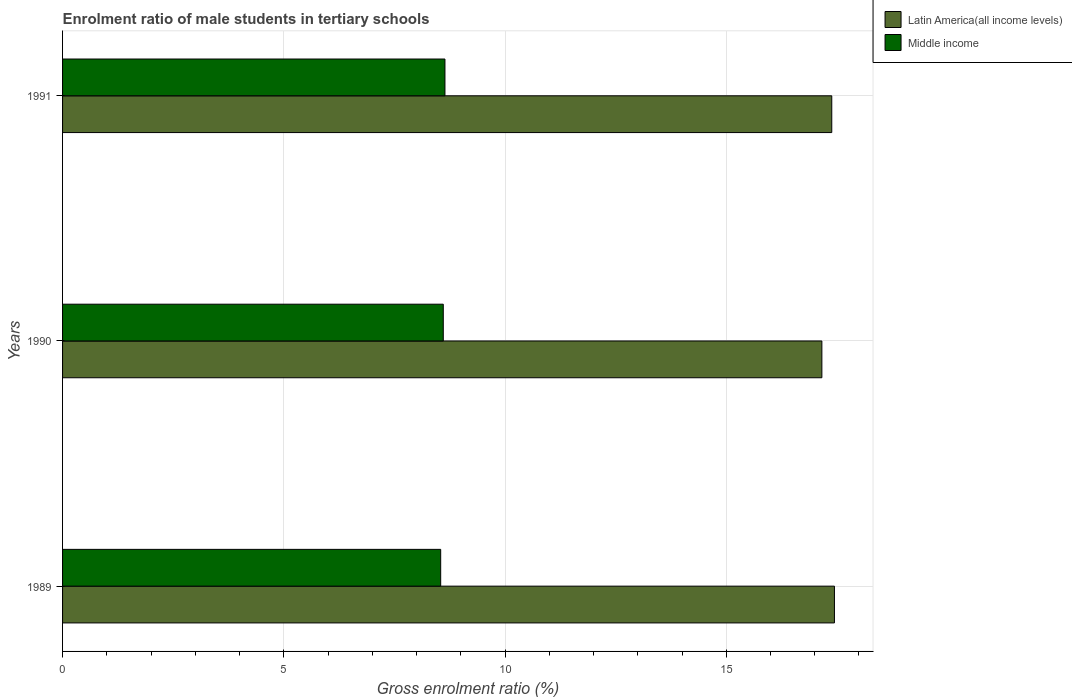How many different coloured bars are there?
Keep it short and to the point. 2. Are the number of bars per tick equal to the number of legend labels?
Provide a short and direct response. Yes. Are the number of bars on each tick of the Y-axis equal?
Offer a very short reply. Yes. How many bars are there on the 3rd tick from the top?
Provide a succinct answer. 2. What is the label of the 1st group of bars from the top?
Provide a succinct answer. 1991. In how many cases, is the number of bars for a given year not equal to the number of legend labels?
Your answer should be compact. 0. What is the enrolment ratio of male students in tertiary schools in Latin America(all income levels) in 1991?
Provide a short and direct response. 17.38. Across all years, what is the maximum enrolment ratio of male students in tertiary schools in Middle income?
Your response must be concise. 8.64. Across all years, what is the minimum enrolment ratio of male students in tertiary schools in Middle income?
Offer a very short reply. 8.55. What is the total enrolment ratio of male students in tertiary schools in Middle income in the graph?
Offer a terse response. 25.79. What is the difference between the enrolment ratio of male students in tertiary schools in Latin America(all income levels) in 1990 and that in 1991?
Your answer should be compact. -0.22. What is the difference between the enrolment ratio of male students in tertiary schools in Middle income in 1990 and the enrolment ratio of male students in tertiary schools in Latin America(all income levels) in 1991?
Keep it short and to the point. -8.78. What is the average enrolment ratio of male students in tertiary schools in Latin America(all income levels) per year?
Offer a terse response. 17.33. In the year 1991, what is the difference between the enrolment ratio of male students in tertiary schools in Latin America(all income levels) and enrolment ratio of male students in tertiary schools in Middle income?
Give a very brief answer. 8.74. What is the ratio of the enrolment ratio of male students in tertiary schools in Middle income in 1989 to that in 1990?
Provide a succinct answer. 0.99. Is the enrolment ratio of male students in tertiary schools in Latin America(all income levels) in 1990 less than that in 1991?
Ensure brevity in your answer.  Yes. Is the difference between the enrolment ratio of male students in tertiary schools in Latin America(all income levels) in 1990 and 1991 greater than the difference between the enrolment ratio of male students in tertiary schools in Middle income in 1990 and 1991?
Offer a terse response. No. What is the difference between the highest and the second highest enrolment ratio of male students in tertiary schools in Middle income?
Give a very brief answer. 0.04. What is the difference between the highest and the lowest enrolment ratio of male students in tertiary schools in Middle income?
Your answer should be compact. 0.1. What does the 2nd bar from the top in 1991 represents?
Give a very brief answer. Latin America(all income levels). How many bars are there?
Ensure brevity in your answer.  6. How many years are there in the graph?
Keep it short and to the point. 3. What is the difference between two consecutive major ticks on the X-axis?
Provide a short and direct response. 5. Are the values on the major ticks of X-axis written in scientific E-notation?
Keep it short and to the point. No. Does the graph contain any zero values?
Give a very brief answer. No. Does the graph contain grids?
Offer a terse response. Yes. How many legend labels are there?
Your answer should be very brief. 2. What is the title of the graph?
Your response must be concise. Enrolment ratio of male students in tertiary schools. What is the label or title of the X-axis?
Offer a terse response. Gross enrolment ratio (%). What is the Gross enrolment ratio (%) of Latin America(all income levels) in 1989?
Provide a short and direct response. 17.45. What is the Gross enrolment ratio (%) in Middle income in 1989?
Offer a terse response. 8.55. What is the Gross enrolment ratio (%) of Latin America(all income levels) in 1990?
Your answer should be very brief. 17.16. What is the Gross enrolment ratio (%) of Middle income in 1990?
Keep it short and to the point. 8.6. What is the Gross enrolment ratio (%) of Latin America(all income levels) in 1991?
Offer a very short reply. 17.38. What is the Gross enrolment ratio (%) in Middle income in 1991?
Your answer should be very brief. 8.64. Across all years, what is the maximum Gross enrolment ratio (%) in Latin America(all income levels)?
Offer a very short reply. 17.45. Across all years, what is the maximum Gross enrolment ratio (%) of Middle income?
Your answer should be very brief. 8.64. Across all years, what is the minimum Gross enrolment ratio (%) in Latin America(all income levels)?
Your answer should be very brief. 17.16. Across all years, what is the minimum Gross enrolment ratio (%) of Middle income?
Give a very brief answer. 8.55. What is the total Gross enrolment ratio (%) of Latin America(all income levels) in the graph?
Your response must be concise. 51.99. What is the total Gross enrolment ratio (%) of Middle income in the graph?
Offer a very short reply. 25.79. What is the difference between the Gross enrolment ratio (%) in Latin America(all income levels) in 1989 and that in 1990?
Provide a succinct answer. 0.28. What is the difference between the Gross enrolment ratio (%) of Middle income in 1989 and that in 1990?
Provide a short and direct response. -0.06. What is the difference between the Gross enrolment ratio (%) of Latin America(all income levels) in 1989 and that in 1991?
Ensure brevity in your answer.  0.06. What is the difference between the Gross enrolment ratio (%) in Middle income in 1989 and that in 1991?
Make the answer very short. -0.1. What is the difference between the Gross enrolment ratio (%) of Latin America(all income levels) in 1990 and that in 1991?
Give a very brief answer. -0.22. What is the difference between the Gross enrolment ratio (%) in Middle income in 1990 and that in 1991?
Your answer should be compact. -0.04. What is the difference between the Gross enrolment ratio (%) in Latin America(all income levels) in 1989 and the Gross enrolment ratio (%) in Middle income in 1990?
Your response must be concise. 8.84. What is the difference between the Gross enrolment ratio (%) of Latin America(all income levels) in 1989 and the Gross enrolment ratio (%) of Middle income in 1991?
Your answer should be very brief. 8.8. What is the difference between the Gross enrolment ratio (%) in Latin America(all income levels) in 1990 and the Gross enrolment ratio (%) in Middle income in 1991?
Keep it short and to the point. 8.52. What is the average Gross enrolment ratio (%) of Latin America(all income levels) per year?
Offer a very short reply. 17.33. What is the average Gross enrolment ratio (%) of Middle income per year?
Offer a terse response. 8.6. In the year 1989, what is the difference between the Gross enrolment ratio (%) in Latin America(all income levels) and Gross enrolment ratio (%) in Middle income?
Make the answer very short. 8.9. In the year 1990, what is the difference between the Gross enrolment ratio (%) of Latin America(all income levels) and Gross enrolment ratio (%) of Middle income?
Offer a very short reply. 8.56. In the year 1991, what is the difference between the Gross enrolment ratio (%) of Latin America(all income levels) and Gross enrolment ratio (%) of Middle income?
Offer a very short reply. 8.74. What is the ratio of the Gross enrolment ratio (%) of Latin America(all income levels) in 1989 to that in 1990?
Make the answer very short. 1.02. What is the ratio of the Gross enrolment ratio (%) of Latin America(all income levels) in 1989 to that in 1991?
Your answer should be compact. 1. What is the ratio of the Gross enrolment ratio (%) in Latin America(all income levels) in 1990 to that in 1991?
Offer a terse response. 0.99. What is the difference between the highest and the second highest Gross enrolment ratio (%) of Latin America(all income levels)?
Keep it short and to the point. 0.06. What is the difference between the highest and the second highest Gross enrolment ratio (%) in Middle income?
Keep it short and to the point. 0.04. What is the difference between the highest and the lowest Gross enrolment ratio (%) of Latin America(all income levels)?
Your response must be concise. 0.28. What is the difference between the highest and the lowest Gross enrolment ratio (%) in Middle income?
Provide a short and direct response. 0.1. 